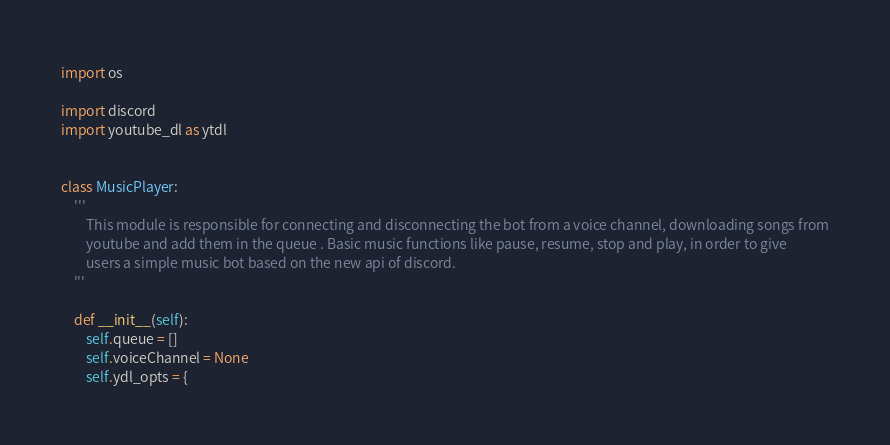Convert code to text. <code><loc_0><loc_0><loc_500><loc_500><_Python_>import os

import discord
import youtube_dl as ytdl


class MusicPlayer:
    '''
        This module is responsible for connecting and disconnecting the bot from a voice channel, downloading songs from
        youtube and add them in the queue . Basic music functions like pause, resume, stop and play, in order to give
        users a simple music bot based on the new api of discord.
    '''

    def __init__(self):
        self.queue = []
        self.voiceChannel = None
        self.ydl_opts = {</code> 